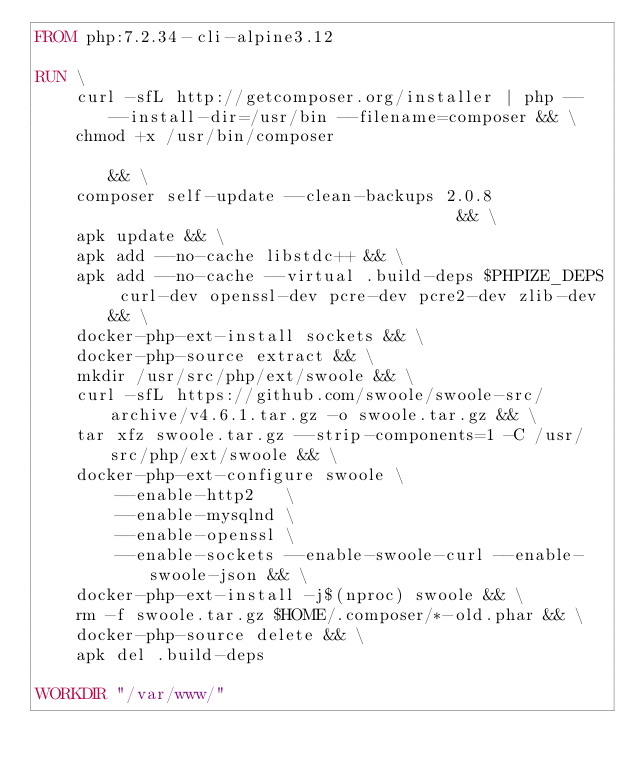<code> <loc_0><loc_0><loc_500><loc_500><_Dockerfile_>FROM php:7.2.34-cli-alpine3.12

RUN \
    curl -sfL http://getcomposer.org/installer | php -- --install-dir=/usr/bin --filename=composer && \
    chmod +x /usr/bin/composer                                                                     && \
    composer self-update --clean-backups 2.0.8                                    && \
    apk update && \
    apk add --no-cache libstdc++ && \
    apk add --no-cache --virtual .build-deps $PHPIZE_DEPS curl-dev openssl-dev pcre-dev pcre2-dev zlib-dev && \
    docker-php-ext-install sockets && \
    docker-php-source extract && \
    mkdir /usr/src/php/ext/swoole && \
    curl -sfL https://github.com/swoole/swoole-src/archive/v4.6.1.tar.gz -o swoole.tar.gz && \
    tar xfz swoole.tar.gz --strip-components=1 -C /usr/src/php/ext/swoole && \
    docker-php-ext-configure swoole \
        --enable-http2   \
        --enable-mysqlnd \
        --enable-openssl \
        --enable-sockets --enable-swoole-curl --enable-swoole-json && \
    docker-php-ext-install -j$(nproc) swoole && \
    rm -f swoole.tar.gz $HOME/.composer/*-old.phar && \
    docker-php-source delete && \
    apk del .build-deps

WORKDIR "/var/www/"
</code> 